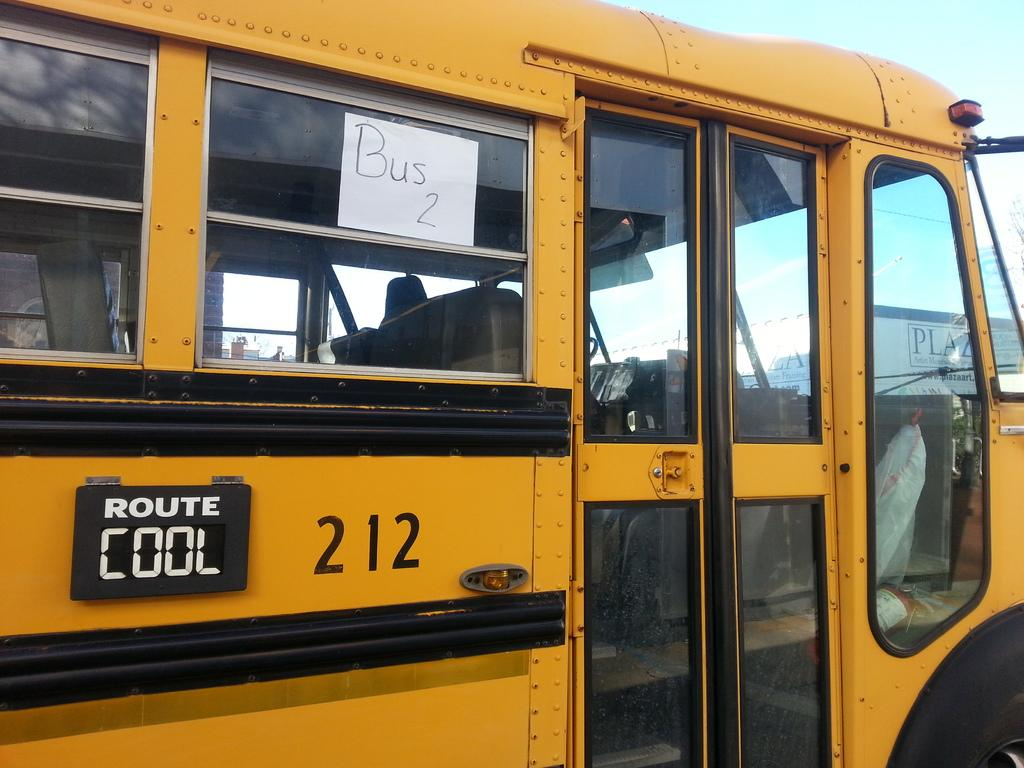<image>
Create a compact narrative representing the image presented. The yellow school bus number 212 is bus 2 and on Route Cool. 